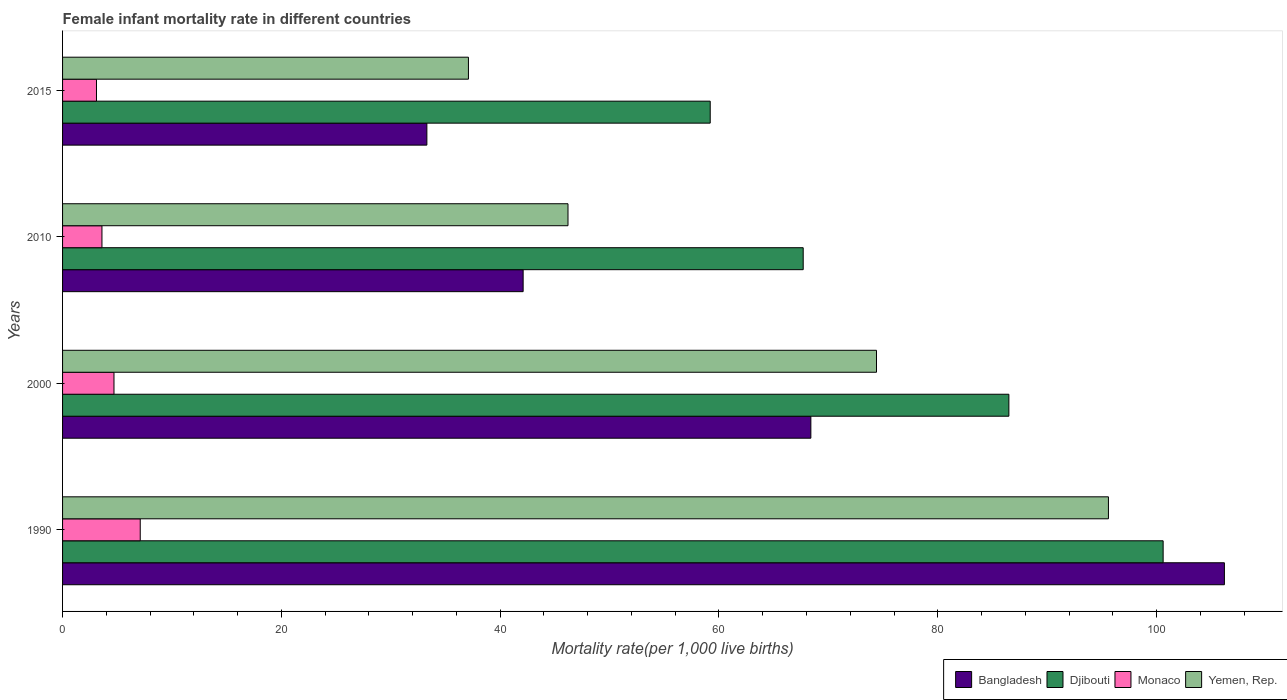Are the number of bars per tick equal to the number of legend labels?
Provide a succinct answer. Yes. How many bars are there on the 2nd tick from the bottom?
Give a very brief answer. 4. In how many cases, is the number of bars for a given year not equal to the number of legend labels?
Offer a very short reply. 0. What is the female infant mortality rate in Yemen, Rep. in 2015?
Provide a succinct answer. 37.1. Across all years, what is the maximum female infant mortality rate in Djibouti?
Your answer should be very brief. 100.6. Across all years, what is the minimum female infant mortality rate in Bangladesh?
Give a very brief answer. 33.3. In which year was the female infant mortality rate in Bangladesh maximum?
Your response must be concise. 1990. In which year was the female infant mortality rate in Monaco minimum?
Your answer should be compact. 2015. What is the total female infant mortality rate in Yemen, Rep. in the graph?
Provide a succinct answer. 253.3. What is the difference between the female infant mortality rate in Yemen, Rep. in 2000 and that in 2010?
Ensure brevity in your answer.  28.2. What is the difference between the female infant mortality rate in Bangladesh in 1990 and the female infant mortality rate in Monaco in 2010?
Your answer should be very brief. 102.6. What is the average female infant mortality rate in Bangladesh per year?
Your response must be concise. 62.5. In the year 2010, what is the difference between the female infant mortality rate in Yemen, Rep. and female infant mortality rate in Djibouti?
Your answer should be compact. -21.5. What is the ratio of the female infant mortality rate in Yemen, Rep. in 2000 to that in 2015?
Give a very brief answer. 2.01. Is the female infant mortality rate in Monaco in 2000 less than that in 2015?
Offer a terse response. No. What is the difference between the highest and the second highest female infant mortality rate in Bangladesh?
Your answer should be compact. 37.8. What is the difference between the highest and the lowest female infant mortality rate in Yemen, Rep.?
Your answer should be compact. 58.5. What does the 3rd bar from the top in 2010 represents?
Provide a short and direct response. Djibouti. What does the 2nd bar from the bottom in 1990 represents?
Ensure brevity in your answer.  Djibouti. Is it the case that in every year, the sum of the female infant mortality rate in Bangladesh and female infant mortality rate in Djibouti is greater than the female infant mortality rate in Yemen, Rep.?
Your answer should be very brief. Yes. Are all the bars in the graph horizontal?
Offer a terse response. Yes. How many years are there in the graph?
Ensure brevity in your answer.  4. What is the difference between two consecutive major ticks on the X-axis?
Offer a terse response. 20. Does the graph contain any zero values?
Make the answer very short. No. Does the graph contain grids?
Give a very brief answer. No. Where does the legend appear in the graph?
Make the answer very short. Bottom right. How are the legend labels stacked?
Your answer should be compact. Horizontal. What is the title of the graph?
Provide a short and direct response. Female infant mortality rate in different countries. What is the label or title of the X-axis?
Your response must be concise. Mortality rate(per 1,0 live births). What is the label or title of the Y-axis?
Provide a succinct answer. Years. What is the Mortality rate(per 1,000 live births) of Bangladesh in 1990?
Ensure brevity in your answer.  106.2. What is the Mortality rate(per 1,000 live births) of Djibouti in 1990?
Ensure brevity in your answer.  100.6. What is the Mortality rate(per 1,000 live births) in Yemen, Rep. in 1990?
Make the answer very short. 95.6. What is the Mortality rate(per 1,000 live births) in Bangladesh in 2000?
Your answer should be compact. 68.4. What is the Mortality rate(per 1,000 live births) in Djibouti in 2000?
Your response must be concise. 86.5. What is the Mortality rate(per 1,000 live births) in Yemen, Rep. in 2000?
Make the answer very short. 74.4. What is the Mortality rate(per 1,000 live births) in Bangladesh in 2010?
Make the answer very short. 42.1. What is the Mortality rate(per 1,000 live births) of Djibouti in 2010?
Offer a terse response. 67.7. What is the Mortality rate(per 1,000 live births) in Monaco in 2010?
Give a very brief answer. 3.6. What is the Mortality rate(per 1,000 live births) in Yemen, Rep. in 2010?
Offer a very short reply. 46.2. What is the Mortality rate(per 1,000 live births) of Bangladesh in 2015?
Your response must be concise. 33.3. What is the Mortality rate(per 1,000 live births) of Djibouti in 2015?
Keep it short and to the point. 59.2. What is the Mortality rate(per 1,000 live births) of Yemen, Rep. in 2015?
Offer a terse response. 37.1. Across all years, what is the maximum Mortality rate(per 1,000 live births) of Bangladesh?
Ensure brevity in your answer.  106.2. Across all years, what is the maximum Mortality rate(per 1,000 live births) in Djibouti?
Keep it short and to the point. 100.6. Across all years, what is the maximum Mortality rate(per 1,000 live births) in Yemen, Rep.?
Your answer should be compact. 95.6. Across all years, what is the minimum Mortality rate(per 1,000 live births) in Bangladesh?
Offer a terse response. 33.3. Across all years, what is the minimum Mortality rate(per 1,000 live births) of Djibouti?
Provide a short and direct response. 59.2. Across all years, what is the minimum Mortality rate(per 1,000 live births) in Yemen, Rep.?
Keep it short and to the point. 37.1. What is the total Mortality rate(per 1,000 live births) in Bangladesh in the graph?
Keep it short and to the point. 250. What is the total Mortality rate(per 1,000 live births) in Djibouti in the graph?
Give a very brief answer. 314. What is the total Mortality rate(per 1,000 live births) of Monaco in the graph?
Offer a terse response. 18.5. What is the total Mortality rate(per 1,000 live births) of Yemen, Rep. in the graph?
Make the answer very short. 253.3. What is the difference between the Mortality rate(per 1,000 live births) in Bangladesh in 1990 and that in 2000?
Your answer should be compact. 37.8. What is the difference between the Mortality rate(per 1,000 live births) in Yemen, Rep. in 1990 and that in 2000?
Provide a succinct answer. 21.2. What is the difference between the Mortality rate(per 1,000 live births) in Bangladesh in 1990 and that in 2010?
Offer a terse response. 64.1. What is the difference between the Mortality rate(per 1,000 live births) in Djibouti in 1990 and that in 2010?
Provide a short and direct response. 32.9. What is the difference between the Mortality rate(per 1,000 live births) of Yemen, Rep. in 1990 and that in 2010?
Give a very brief answer. 49.4. What is the difference between the Mortality rate(per 1,000 live births) in Bangladesh in 1990 and that in 2015?
Make the answer very short. 72.9. What is the difference between the Mortality rate(per 1,000 live births) of Djibouti in 1990 and that in 2015?
Keep it short and to the point. 41.4. What is the difference between the Mortality rate(per 1,000 live births) in Yemen, Rep. in 1990 and that in 2015?
Ensure brevity in your answer.  58.5. What is the difference between the Mortality rate(per 1,000 live births) in Bangladesh in 2000 and that in 2010?
Your answer should be very brief. 26.3. What is the difference between the Mortality rate(per 1,000 live births) of Monaco in 2000 and that in 2010?
Give a very brief answer. 1.1. What is the difference between the Mortality rate(per 1,000 live births) of Yemen, Rep. in 2000 and that in 2010?
Make the answer very short. 28.2. What is the difference between the Mortality rate(per 1,000 live births) in Bangladesh in 2000 and that in 2015?
Provide a succinct answer. 35.1. What is the difference between the Mortality rate(per 1,000 live births) of Djibouti in 2000 and that in 2015?
Provide a short and direct response. 27.3. What is the difference between the Mortality rate(per 1,000 live births) of Monaco in 2000 and that in 2015?
Your answer should be compact. 1.6. What is the difference between the Mortality rate(per 1,000 live births) in Yemen, Rep. in 2000 and that in 2015?
Give a very brief answer. 37.3. What is the difference between the Mortality rate(per 1,000 live births) in Yemen, Rep. in 2010 and that in 2015?
Offer a terse response. 9.1. What is the difference between the Mortality rate(per 1,000 live births) in Bangladesh in 1990 and the Mortality rate(per 1,000 live births) in Monaco in 2000?
Offer a very short reply. 101.5. What is the difference between the Mortality rate(per 1,000 live births) in Bangladesh in 1990 and the Mortality rate(per 1,000 live births) in Yemen, Rep. in 2000?
Your response must be concise. 31.8. What is the difference between the Mortality rate(per 1,000 live births) of Djibouti in 1990 and the Mortality rate(per 1,000 live births) of Monaco in 2000?
Give a very brief answer. 95.9. What is the difference between the Mortality rate(per 1,000 live births) of Djibouti in 1990 and the Mortality rate(per 1,000 live births) of Yemen, Rep. in 2000?
Your answer should be compact. 26.2. What is the difference between the Mortality rate(per 1,000 live births) of Monaco in 1990 and the Mortality rate(per 1,000 live births) of Yemen, Rep. in 2000?
Your answer should be very brief. -67.3. What is the difference between the Mortality rate(per 1,000 live births) in Bangladesh in 1990 and the Mortality rate(per 1,000 live births) in Djibouti in 2010?
Give a very brief answer. 38.5. What is the difference between the Mortality rate(per 1,000 live births) of Bangladesh in 1990 and the Mortality rate(per 1,000 live births) of Monaco in 2010?
Offer a very short reply. 102.6. What is the difference between the Mortality rate(per 1,000 live births) of Djibouti in 1990 and the Mortality rate(per 1,000 live births) of Monaco in 2010?
Keep it short and to the point. 97. What is the difference between the Mortality rate(per 1,000 live births) of Djibouti in 1990 and the Mortality rate(per 1,000 live births) of Yemen, Rep. in 2010?
Make the answer very short. 54.4. What is the difference between the Mortality rate(per 1,000 live births) of Monaco in 1990 and the Mortality rate(per 1,000 live births) of Yemen, Rep. in 2010?
Give a very brief answer. -39.1. What is the difference between the Mortality rate(per 1,000 live births) in Bangladesh in 1990 and the Mortality rate(per 1,000 live births) in Monaco in 2015?
Keep it short and to the point. 103.1. What is the difference between the Mortality rate(per 1,000 live births) in Bangladesh in 1990 and the Mortality rate(per 1,000 live births) in Yemen, Rep. in 2015?
Your answer should be compact. 69.1. What is the difference between the Mortality rate(per 1,000 live births) of Djibouti in 1990 and the Mortality rate(per 1,000 live births) of Monaco in 2015?
Offer a very short reply. 97.5. What is the difference between the Mortality rate(per 1,000 live births) of Djibouti in 1990 and the Mortality rate(per 1,000 live births) of Yemen, Rep. in 2015?
Keep it short and to the point. 63.5. What is the difference between the Mortality rate(per 1,000 live births) of Monaco in 1990 and the Mortality rate(per 1,000 live births) of Yemen, Rep. in 2015?
Your answer should be very brief. -30. What is the difference between the Mortality rate(per 1,000 live births) in Bangladesh in 2000 and the Mortality rate(per 1,000 live births) in Monaco in 2010?
Offer a very short reply. 64.8. What is the difference between the Mortality rate(per 1,000 live births) of Djibouti in 2000 and the Mortality rate(per 1,000 live births) of Monaco in 2010?
Offer a terse response. 82.9. What is the difference between the Mortality rate(per 1,000 live births) in Djibouti in 2000 and the Mortality rate(per 1,000 live births) in Yemen, Rep. in 2010?
Keep it short and to the point. 40.3. What is the difference between the Mortality rate(per 1,000 live births) of Monaco in 2000 and the Mortality rate(per 1,000 live births) of Yemen, Rep. in 2010?
Provide a short and direct response. -41.5. What is the difference between the Mortality rate(per 1,000 live births) in Bangladesh in 2000 and the Mortality rate(per 1,000 live births) in Djibouti in 2015?
Provide a succinct answer. 9.2. What is the difference between the Mortality rate(per 1,000 live births) in Bangladesh in 2000 and the Mortality rate(per 1,000 live births) in Monaco in 2015?
Give a very brief answer. 65.3. What is the difference between the Mortality rate(per 1,000 live births) in Bangladesh in 2000 and the Mortality rate(per 1,000 live births) in Yemen, Rep. in 2015?
Your answer should be very brief. 31.3. What is the difference between the Mortality rate(per 1,000 live births) of Djibouti in 2000 and the Mortality rate(per 1,000 live births) of Monaco in 2015?
Your response must be concise. 83.4. What is the difference between the Mortality rate(per 1,000 live births) in Djibouti in 2000 and the Mortality rate(per 1,000 live births) in Yemen, Rep. in 2015?
Offer a very short reply. 49.4. What is the difference between the Mortality rate(per 1,000 live births) in Monaco in 2000 and the Mortality rate(per 1,000 live births) in Yemen, Rep. in 2015?
Provide a short and direct response. -32.4. What is the difference between the Mortality rate(per 1,000 live births) of Bangladesh in 2010 and the Mortality rate(per 1,000 live births) of Djibouti in 2015?
Your response must be concise. -17.1. What is the difference between the Mortality rate(per 1,000 live births) of Djibouti in 2010 and the Mortality rate(per 1,000 live births) of Monaco in 2015?
Give a very brief answer. 64.6. What is the difference between the Mortality rate(per 1,000 live births) in Djibouti in 2010 and the Mortality rate(per 1,000 live births) in Yemen, Rep. in 2015?
Offer a terse response. 30.6. What is the difference between the Mortality rate(per 1,000 live births) in Monaco in 2010 and the Mortality rate(per 1,000 live births) in Yemen, Rep. in 2015?
Provide a succinct answer. -33.5. What is the average Mortality rate(per 1,000 live births) in Bangladesh per year?
Your answer should be very brief. 62.5. What is the average Mortality rate(per 1,000 live births) in Djibouti per year?
Give a very brief answer. 78.5. What is the average Mortality rate(per 1,000 live births) in Monaco per year?
Give a very brief answer. 4.62. What is the average Mortality rate(per 1,000 live births) in Yemen, Rep. per year?
Keep it short and to the point. 63.33. In the year 1990, what is the difference between the Mortality rate(per 1,000 live births) of Bangladesh and Mortality rate(per 1,000 live births) of Djibouti?
Your answer should be compact. 5.6. In the year 1990, what is the difference between the Mortality rate(per 1,000 live births) of Bangladesh and Mortality rate(per 1,000 live births) of Monaco?
Ensure brevity in your answer.  99.1. In the year 1990, what is the difference between the Mortality rate(per 1,000 live births) in Djibouti and Mortality rate(per 1,000 live births) in Monaco?
Give a very brief answer. 93.5. In the year 1990, what is the difference between the Mortality rate(per 1,000 live births) of Djibouti and Mortality rate(per 1,000 live births) of Yemen, Rep.?
Your answer should be very brief. 5. In the year 1990, what is the difference between the Mortality rate(per 1,000 live births) in Monaco and Mortality rate(per 1,000 live births) in Yemen, Rep.?
Keep it short and to the point. -88.5. In the year 2000, what is the difference between the Mortality rate(per 1,000 live births) of Bangladesh and Mortality rate(per 1,000 live births) of Djibouti?
Provide a succinct answer. -18.1. In the year 2000, what is the difference between the Mortality rate(per 1,000 live births) of Bangladesh and Mortality rate(per 1,000 live births) of Monaco?
Keep it short and to the point. 63.7. In the year 2000, what is the difference between the Mortality rate(per 1,000 live births) in Djibouti and Mortality rate(per 1,000 live births) in Monaco?
Provide a short and direct response. 81.8. In the year 2000, what is the difference between the Mortality rate(per 1,000 live births) of Monaco and Mortality rate(per 1,000 live births) of Yemen, Rep.?
Your response must be concise. -69.7. In the year 2010, what is the difference between the Mortality rate(per 1,000 live births) in Bangladesh and Mortality rate(per 1,000 live births) in Djibouti?
Keep it short and to the point. -25.6. In the year 2010, what is the difference between the Mortality rate(per 1,000 live births) in Bangladesh and Mortality rate(per 1,000 live births) in Monaco?
Provide a short and direct response. 38.5. In the year 2010, what is the difference between the Mortality rate(per 1,000 live births) in Bangladesh and Mortality rate(per 1,000 live births) in Yemen, Rep.?
Provide a short and direct response. -4.1. In the year 2010, what is the difference between the Mortality rate(per 1,000 live births) of Djibouti and Mortality rate(per 1,000 live births) of Monaco?
Offer a very short reply. 64.1. In the year 2010, what is the difference between the Mortality rate(per 1,000 live births) in Monaco and Mortality rate(per 1,000 live births) in Yemen, Rep.?
Provide a succinct answer. -42.6. In the year 2015, what is the difference between the Mortality rate(per 1,000 live births) of Bangladesh and Mortality rate(per 1,000 live births) of Djibouti?
Provide a short and direct response. -25.9. In the year 2015, what is the difference between the Mortality rate(per 1,000 live births) in Bangladesh and Mortality rate(per 1,000 live births) in Monaco?
Your answer should be compact. 30.2. In the year 2015, what is the difference between the Mortality rate(per 1,000 live births) in Djibouti and Mortality rate(per 1,000 live births) in Monaco?
Your answer should be compact. 56.1. In the year 2015, what is the difference between the Mortality rate(per 1,000 live births) in Djibouti and Mortality rate(per 1,000 live births) in Yemen, Rep.?
Make the answer very short. 22.1. In the year 2015, what is the difference between the Mortality rate(per 1,000 live births) in Monaco and Mortality rate(per 1,000 live births) in Yemen, Rep.?
Your answer should be very brief. -34. What is the ratio of the Mortality rate(per 1,000 live births) of Bangladesh in 1990 to that in 2000?
Offer a terse response. 1.55. What is the ratio of the Mortality rate(per 1,000 live births) of Djibouti in 1990 to that in 2000?
Make the answer very short. 1.16. What is the ratio of the Mortality rate(per 1,000 live births) in Monaco in 1990 to that in 2000?
Give a very brief answer. 1.51. What is the ratio of the Mortality rate(per 1,000 live births) of Yemen, Rep. in 1990 to that in 2000?
Provide a short and direct response. 1.28. What is the ratio of the Mortality rate(per 1,000 live births) of Bangladesh in 1990 to that in 2010?
Your answer should be very brief. 2.52. What is the ratio of the Mortality rate(per 1,000 live births) in Djibouti in 1990 to that in 2010?
Your response must be concise. 1.49. What is the ratio of the Mortality rate(per 1,000 live births) in Monaco in 1990 to that in 2010?
Make the answer very short. 1.97. What is the ratio of the Mortality rate(per 1,000 live births) in Yemen, Rep. in 1990 to that in 2010?
Ensure brevity in your answer.  2.07. What is the ratio of the Mortality rate(per 1,000 live births) of Bangladesh in 1990 to that in 2015?
Ensure brevity in your answer.  3.19. What is the ratio of the Mortality rate(per 1,000 live births) in Djibouti in 1990 to that in 2015?
Make the answer very short. 1.7. What is the ratio of the Mortality rate(per 1,000 live births) in Monaco in 1990 to that in 2015?
Provide a short and direct response. 2.29. What is the ratio of the Mortality rate(per 1,000 live births) in Yemen, Rep. in 1990 to that in 2015?
Your answer should be compact. 2.58. What is the ratio of the Mortality rate(per 1,000 live births) of Bangladesh in 2000 to that in 2010?
Your answer should be compact. 1.62. What is the ratio of the Mortality rate(per 1,000 live births) in Djibouti in 2000 to that in 2010?
Your answer should be very brief. 1.28. What is the ratio of the Mortality rate(per 1,000 live births) of Monaco in 2000 to that in 2010?
Offer a terse response. 1.31. What is the ratio of the Mortality rate(per 1,000 live births) of Yemen, Rep. in 2000 to that in 2010?
Give a very brief answer. 1.61. What is the ratio of the Mortality rate(per 1,000 live births) of Bangladesh in 2000 to that in 2015?
Offer a very short reply. 2.05. What is the ratio of the Mortality rate(per 1,000 live births) in Djibouti in 2000 to that in 2015?
Your answer should be compact. 1.46. What is the ratio of the Mortality rate(per 1,000 live births) of Monaco in 2000 to that in 2015?
Keep it short and to the point. 1.52. What is the ratio of the Mortality rate(per 1,000 live births) in Yemen, Rep. in 2000 to that in 2015?
Provide a short and direct response. 2.01. What is the ratio of the Mortality rate(per 1,000 live births) in Bangladesh in 2010 to that in 2015?
Make the answer very short. 1.26. What is the ratio of the Mortality rate(per 1,000 live births) in Djibouti in 2010 to that in 2015?
Provide a short and direct response. 1.14. What is the ratio of the Mortality rate(per 1,000 live births) of Monaco in 2010 to that in 2015?
Make the answer very short. 1.16. What is the ratio of the Mortality rate(per 1,000 live births) in Yemen, Rep. in 2010 to that in 2015?
Offer a very short reply. 1.25. What is the difference between the highest and the second highest Mortality rate(per 1,000 live births) of Bangladesh?
Your answer should be very brief. 37.8. What is the difference between the highest and the second highest Mortality rate(per 1,000 live births) of Djibouti?
Provide a succinct answer. 14.1. What is the difference between the highest and the second highest Mortality rate(per 1,000 live births) in Yemen, Rep.?
Provide a succinct answer. 21.2. What is the difference between the highest and the lowest Mortality rate(per 1,000 live births) of Bangladesh?
Offer a very short reply. 72.9. What is the difference between the highest and the lowest Mortality rate(per 1,000 live births) of Djibouti?
Your answer should be compact. 41.4. What is the difference between the highest and the lowest Mortality rate(per 1,000 live births) in Yemen, Rep.?
Give a very brief answer. 58.5. 